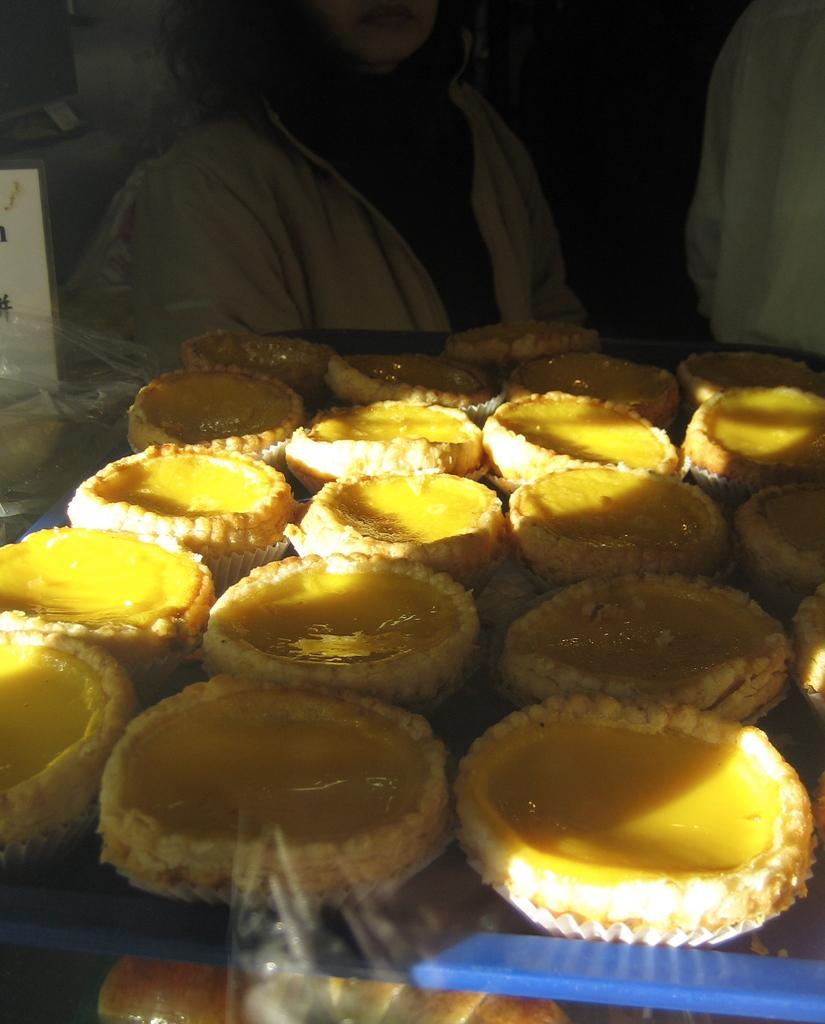What is the color of the tray that holds the food items in the image? The tray is blue in color. What is the color of the food on the tray? The food is in yellow color. Can you describe the person in the background of the image? There is a person wearing a white dress in the background. What type of covering is visible in the image? There is a plastic cover visible in the image. What type of drum is being played by the person in the image? There is no drum present in the image; the person is wearing a white dress in the background. How does the basin contribute to the overall composition of the image? There is no basin present in the image; it only features food items on a blue tray, a person in the background, and a plastic cover. 